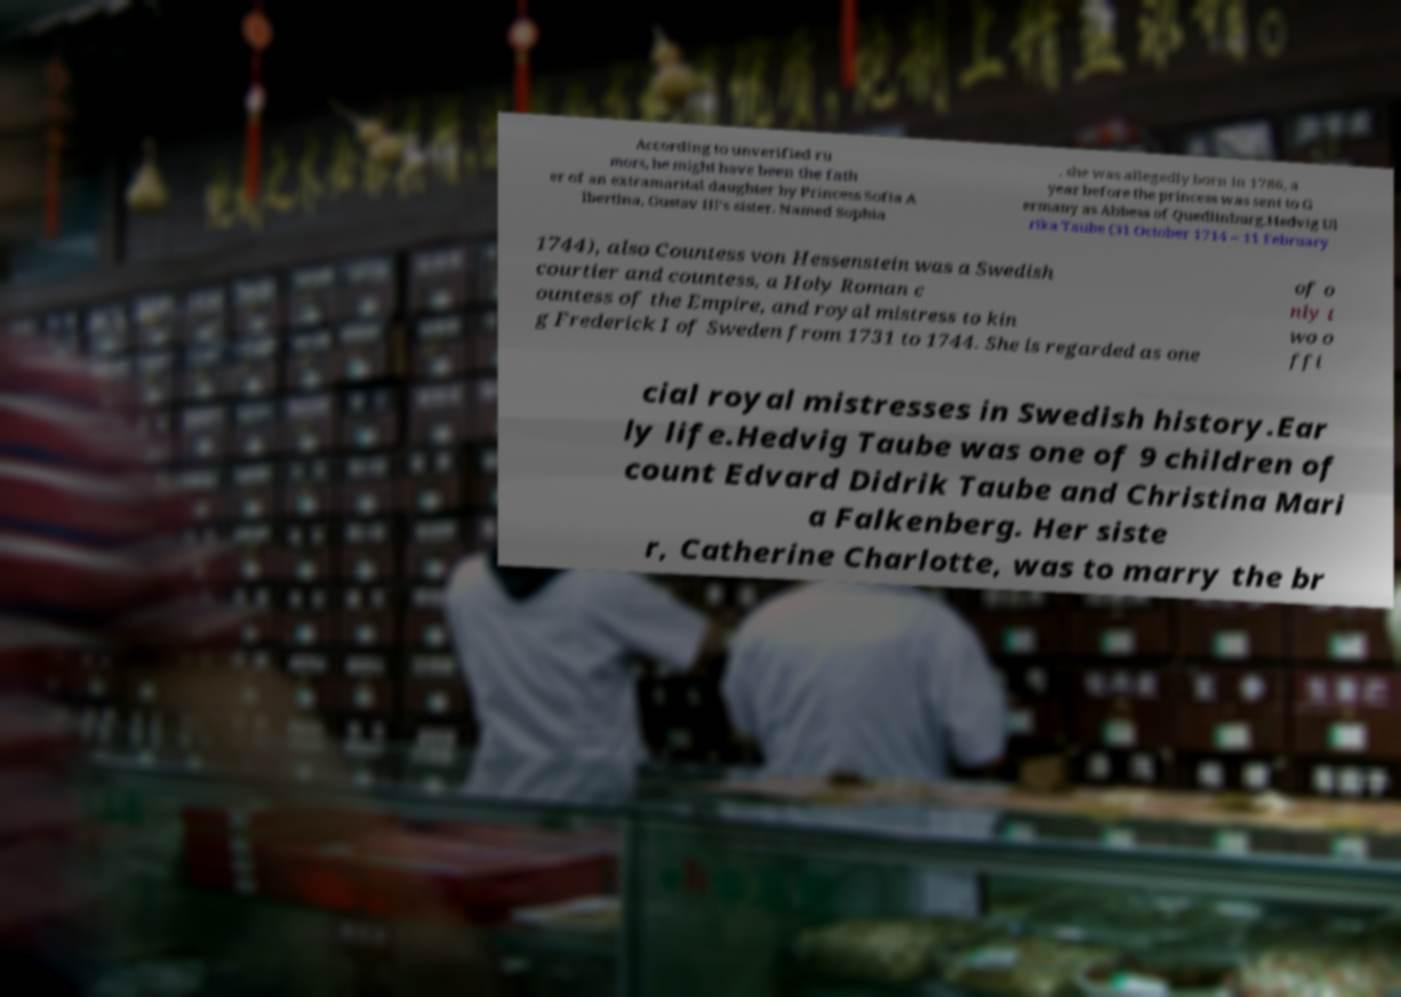Could you assist in decoding the text presented in this image and type it out clearly? According to unverified ru mors, he might have been the fath er of an extramarital daughter by Princess Sofia A lbertina, Gustav III's sister. Named Sophia , she was allegedly born in 1786, a year before the princess was sent to G ermany as Abbess of Quedlinburg.Hedvig Ul rika Taube (31 October 1714 – 11 February 1744), also Countess von Hessenstein was a Swedish courtier and countess, a Holy Roman c ountess of the Empire, and royal mistress to kin g Frederick I of Sweden from 1731 to 1744. She is regarded as one of o nly t wo o ffi cial royal mistresses in Swedish history.Ear ly life.Hedvig Taube was one of 9 children of count Edvard Didrik Taube and Christina Mari a Falkenberg. Her siste r, Catherine Charlotte, was to marry the br 